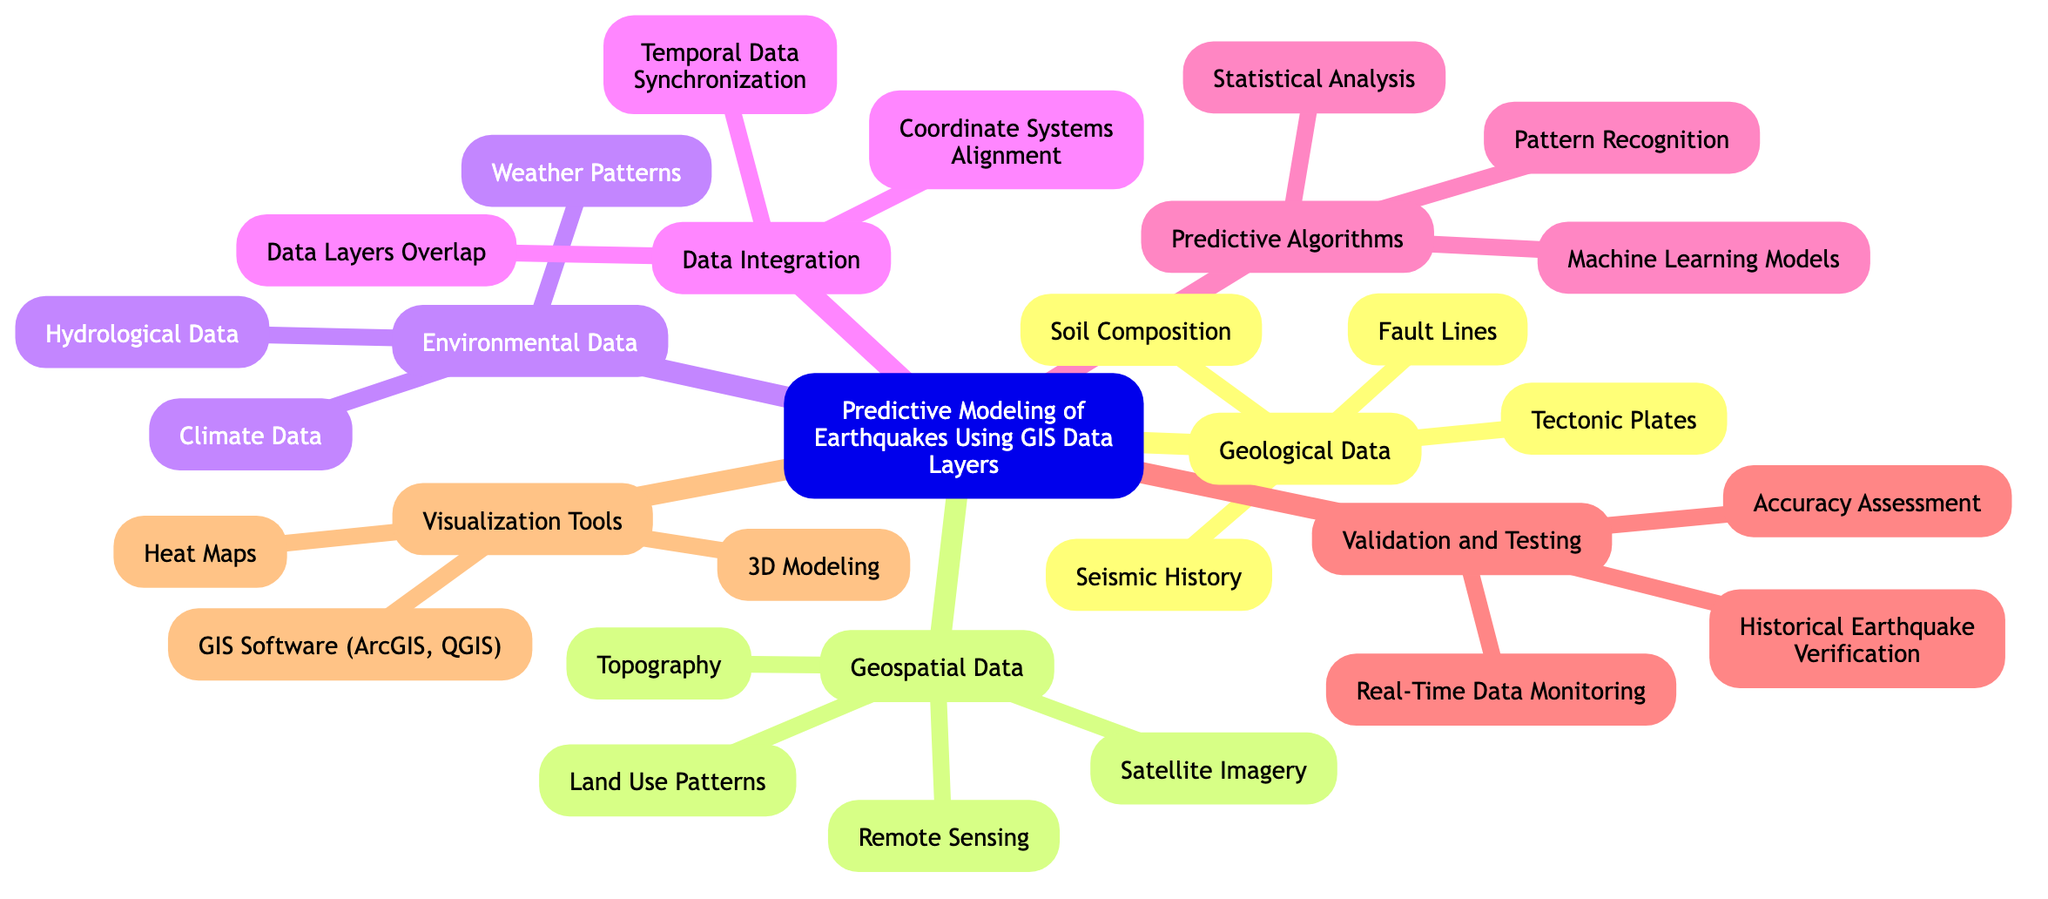What is the central topic of the diagram? The central topic is indicated at the root of the diagram, which is clearly labeled as "Predictive Modeling of Earthquakes Using GIS Data Layers."
Answer: Predictive Modeling of Earthquakes Using GIS Data Layers How many main elements are there in the diagram? The main elements are listed directly under the central topic, and there are a total of six main elements represented.
Answer: Six Which main element includes "Satellite Imagery"? "Satellite Imagery" is listed under the main element "Geospatial Data," which focuses on spatial information related to earth and environment.
Answer: Geospatial Data Name one sub-element of the "Predictive Algorithms" main element. The "Predictive Algorithms" main element contains several sub-elements, one of which is "Machine Learning Models."
Answer: Machine Learning Models What type of analysis is part of the "Validation and Testing" main element? The "Validation and Testing" main element includes "Accuracy Assessment," which evaluates the correctness of the predictive models.
Answer: Accuracy Assessment How do "Fault Lines" contribute to the predictive modeling? "Fault Lines" are a sub-element of "Geological Data," indicating areas of potential earthquakes, thus providing essential data for prediction.
Answer: Essential data for prediction Which visualization tool is mentioned in the diagram? The diagram lists "GIS Software (ArcGIS, QGIS)" as one of the visualization tools, used for mapping and analyzing spatial data.
Answer: GIS Software (ArcGIS, QGIS) What is required for "Data Layers Overlap" in "Data Integration"? "Data Layers Overlap" requires the combination of different data sources to ensure compatibility and comprehensive insight for predictions.
Answer: Combination of different data sources Explain how "Temporal Data Synchronization" aids predictive modeling. "Temporal Data Synchronization" aligns time-based data across different sources, which is crucial for understanding seismic events and improving model accuracy.
Answer: Aligns time-based data across different sources 